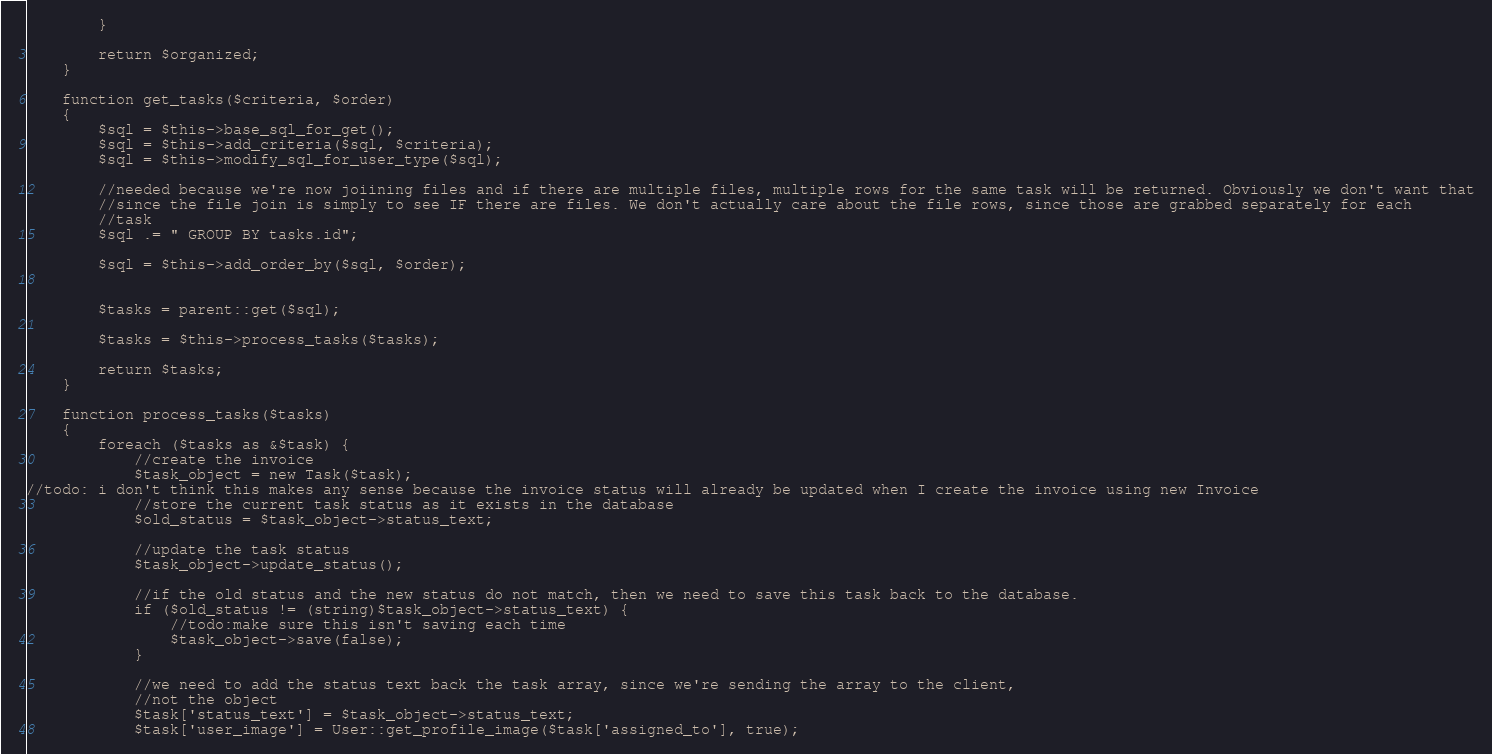<code> <loc_0><loc_0><loc_500><loc_500><_PHP_>        }

        return $organized;
    }

    function get_tasks($criteria, $order)
    {
        $sql = $this->base_sql_for_get();
        $sql = $this->add_criteria($sql, $criteria);
        $sql = $this->modify_sql_for_user_type($sql);

        //needed because we're now joiining files and if there are multiple files, multiple rows for the same task will be returned. Obviously we don't want that
        //since the file join is simply to see IF there are files. We don't actually care about the file rows, since those are grabbed separately for each
        //task
        $sql .= " GROUP BY tasks.id";

        $sql = $this->add_order_by($sql, $order);


        $tasks = parent::get($sql);

        $tasks = $this->process_tasks($tasks);

        return $tasks;
    }

    function process_tasks($tasks)
    {
        foreach ($tasks as &$task) {
            //create the invoice
            $task_object = new Task($task);
//todo: i don't think this makes any sense because the invoice status will already be updated when I create the invoice using new Invoice
            //store the current task status as it exists in the database
            $old_status = $task_object->status_text;

            //update the task status
            $task_object->update_status();

            //if the old status and the new status do not match, then we need to save this task back to the database.
            if ($old_status != (string)$task_object->status_text) {
                //todo:make sure this isn't saving each time
                $task_object->save(false);
            }

            //we need to add the status text back the task array, since we're sending the array to the client,
            //not the object
            $task['status_text'] = $task_object->status_text;
            $task['user_image'] = User::get_profile_image($task['assigned_to'], true);</code> 